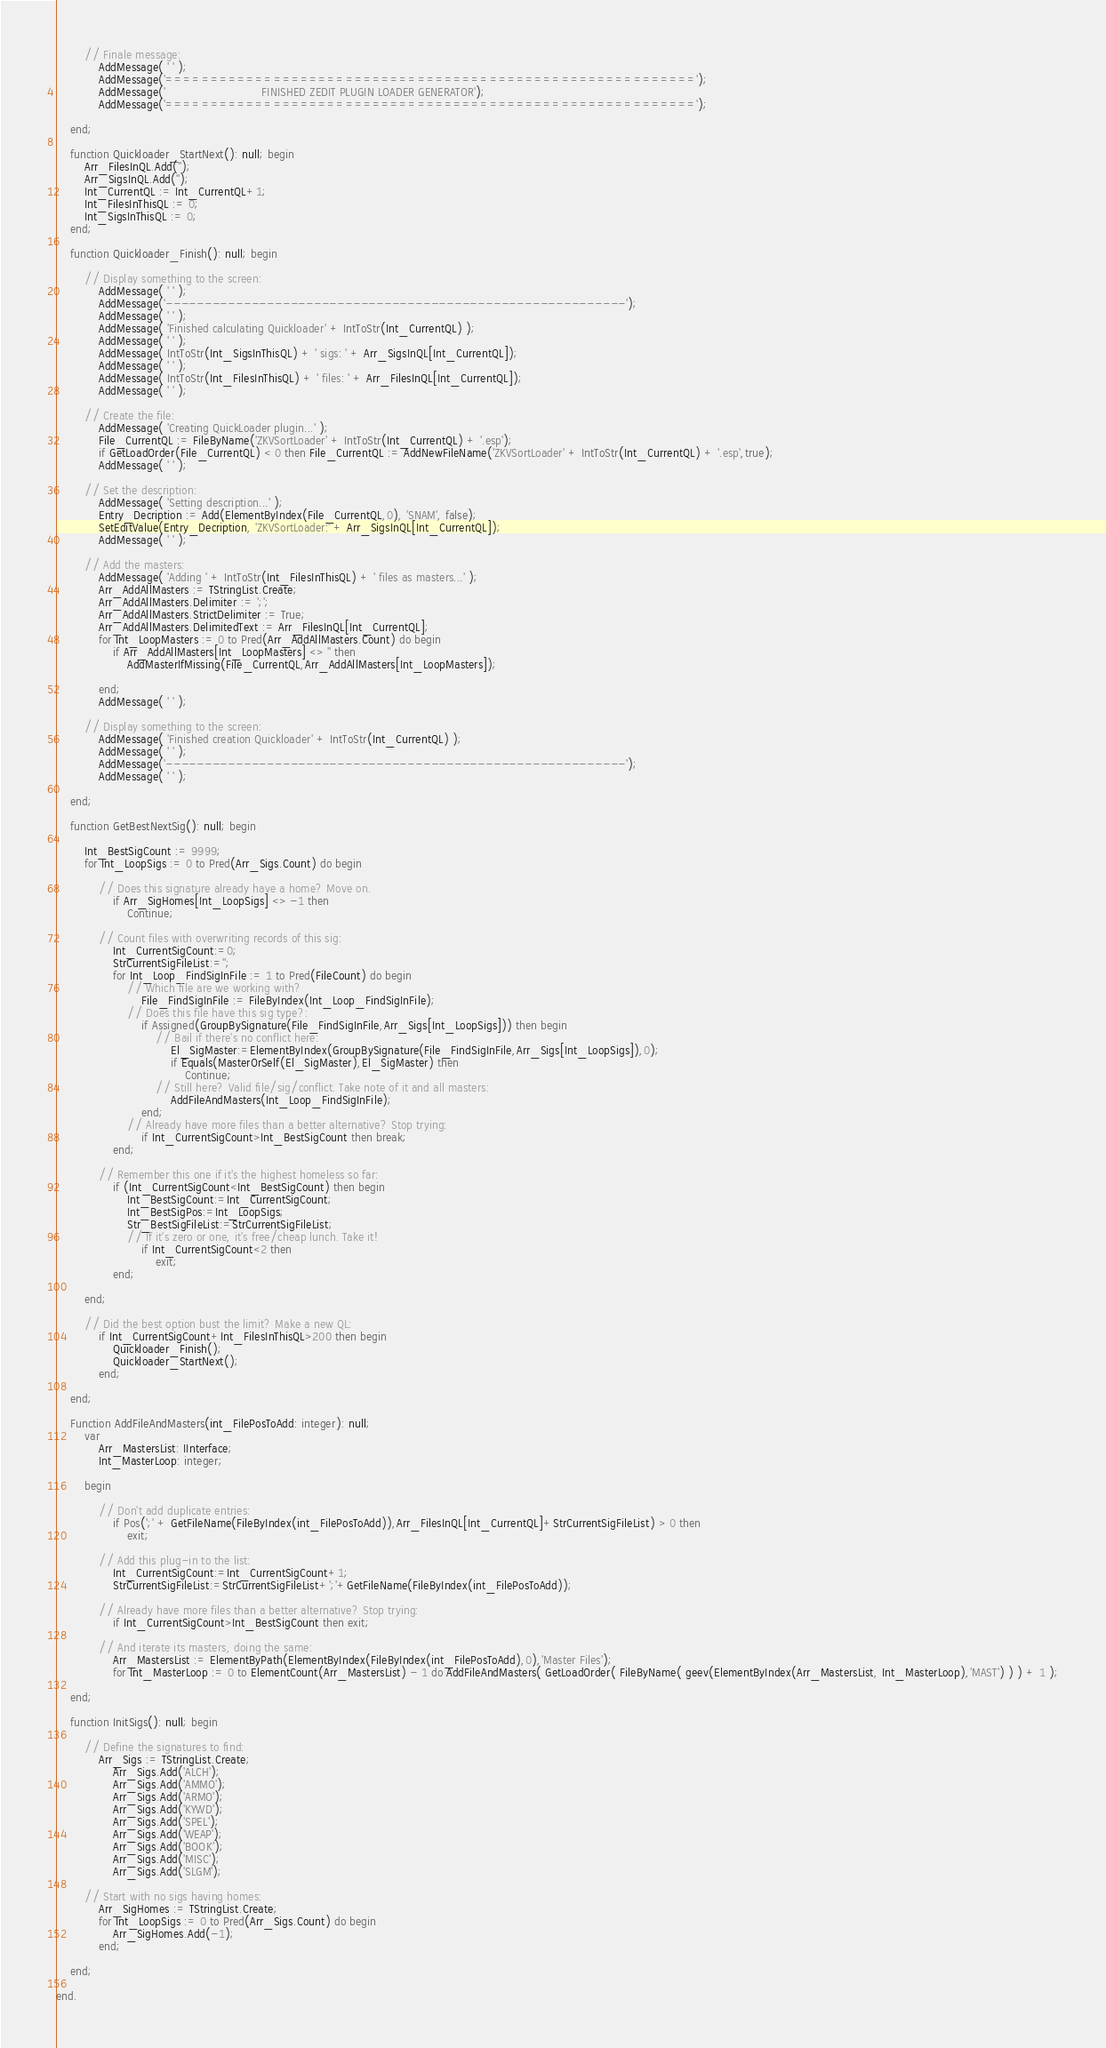Convert code to text. <code><loc_0><loc_0><loc_500><loc_500><_Pascal_>
		// Finale message:
			AddMessage( ' ' );
			AddMessage('===========================================================');
			AddMessage('                           FINISHED ZEDIT PLUGIN LOADER GENERATOR');
			AddMessage('===========================================================');

	end;

	function Quickloader_StartNext(): null; begin
		Arr_FilesInQL.Add('');
		Arr_SigsInQL.Add('');
		Int_CurrentQL := Int_CurrentQL+1;
		Int_FilesInThisQL := 0;
		Int_SigsInThisQL := 0;
	end;

	function Quickloader_Finish(): null; begin

		// Display something to the screen:
			AddMessage( ' ' );
			AddMessage('-----------------------------------------------------------');
			AddMessage( ' ' );
			AddMessage( 'Finished calculating Quickloader' + IntToStr(Int_CurrentQL) );
			AddMessage( ' ' );
			AddMessage( IntToStr(Int_SigsInThisQL) + ' sigs: ' + Arr_SigsInQL[Int_CurrentQL]);
			AddMessage( ' ' );
			AddMessage( IntToStr(Int_FilesInThisQL) + ' files: ' + Arr_FilesInQL[Int_CurrentQL]);
			AddMessage( ' ' );

		// Create the file:
			AddMessage( 'Creating QuickLoader plugin...' );
			File_CurrentQL := FileByName('ZKVSortLoader' + IntToStr(Int_CurrentQL) + '.esp');
			if GetLoadOrder(File_CurrentQL) < 0 then File_CurrentQL := AddNewFileName('ZKVSortLoader' + IntToStr(Int_CurrentQL) + '.esp',true);
			AddMessage( ' ' );

		// Set the description:
			AddMessage( 'Setting description...' );
			Entry_Decription := Add(ElementByIndex(File_CurrentQL,0), 'SNAM', false);
			SetEditValue(Entry_Decription, 'ZKVSortLoader:' + Arr_SigsInQL[Int_CurrentQL]);
			AddMessage( ' ' );

		// Add the masters:
			AddMessage( 'Adding ' + IntToStr(Int_FilesInThisQL) + ' files as masters...' );
			Arr_AddAllMasters := TStringList.Create;
			Arr_AddAllMasters.Delimiter := ';';
			Arr_AddAllMasters.StrictDelimiter := True;
			Arr_AddAllMasters.DelimitedText := Arr_FilesInQL[Int_CurrentQL];
			for Int_LoopMasters := 0 to Pred(Arr_AddAllMasters.Count) do begin
				if Arr_AddAllMasters[Int_LoopMasters] <> '' then
					AddMasterIfMissing(File_CurrentQL,Arr_AddAllMasters[Int_LoopMasters]);

			end;
			AddMessage( ' ' );

		// Display something to the screen:
			AddMessage( 'Finished creation Quickloader' + IntToStr(Int_CurrentQL) );
			AddMessage( ' ' );
			AddMessage('-----------------------------------------------------------');
			AddMessage( ' ' );

	end;

	function GetBestNextSig(): null; begin

		Int_BestSigCount := 9999;
		for Int_LoopSigs := 0 to Pred(Arr_Sigs.Count) do begin

			// Does this signature already have a home? Move on.
				if Arr_SigHomes[Int_LoopSigs] <> -1 then
					Continue;

			// Count files with overwriting records of this sig:
				Int_CurrentSigCount:=0;
				StrCurrentSigFileList:='';
				for Int_Loop_FindSigInFile := 1 to Pred(FileCount) do begin
					// Which file are we working with?
						File_FindSigInFile := FileByIndex(Int_Loop_FindSigInFile);
					// Does this file have this sig type?:
						if Assigned(GroupBySignature(File_FindSigInFile,Arr_Sigs[Int_LoopSigs])) then begin
							// Bail if there's no conflict here:
								El_SigMaster:=ElementByIndex(GroupBySignature(File_FindSigInFile,Arr_Sigs[Int_LoopSigs]),0);
								if Equals(MasterOrSelf(El_SigMaster),El_SigMaster) then
									Continue;
							// Still here? Valid file/sig/conflict. Take note of it and all masters:
								AddFileAndMasters(Int_Loop_FindSigInFile);
						end;
					// Already have more files than a better alternative? Stop trying:
						if Int_CurrentSigCount>Int_BestSigCount then break;
				end;

			// Remember this one if it's the highest homeless so far:
				if (Int_CurrentSigCount<Int_BestSigCount) then begin
					Int_BestSigCount:=Int_CurrentSigCount;
					Int_BestSigPos:=Int_LoopSigs;
					Str_BestSigFileList:=StrCurrentSigFileList;
					// If it's zero or one, it's free/cheap lunch. Take it!
						if Int_CurrentSigCount<2 then
							exit;
				end;

		end;

		// Did the best option bust the limit? Make a new QL:
			if Int_CurrentSigCount+Int_FilesInThisQL>200 then begin
				Quickloader_Finish();
				Quickloader_StartNext();
			end;

	end;

	Function AddFileAndMasters(int_FilePosToAdd: integer): null;
		var
			Arr_MastersList: IInterface;
			Int_MasterLoop: integer;

		begin

			// Don't add duplicate entries:
				if Pos(';' + GetFileName(FileByIndex(int_FilePosToAdd)),Arr_FilesInQL[Int_CurrentQL]+StrCurrentSigFileList) > 0 then
					exit;

			// Add this plug-in to the list:
				Int_CurrentSigCount:=Int_CurrentSigCount+1;
				StrCurrentSigFileList:=StrCurrentSigFileList+';'+GetFileName(FileByIndex(int_FilePosToAdd));

			// Already have more files than a better alternative? Stop trying:
				if Int_CurrentSigCount>Int_BestSigCount then exit;

			// And iterate its masters, doing the same:
				Arr_MastersList := ElementByPath(ElementByIndex(FileByIndex(int_FilePosToAdd),0),'Master Files');
				for Int_MasterLoop := 0 to ElementCount(Arr_MastersList) - 1 do AddFileAndMasters( GetLoadOrder( FileByName( geev(ElementByIndex(Arr_MastersList, Int_MasterLoop),'MAST') ) ) + 1 );

	end;

	function InitSigs(): null; begin

		// Define the signatures to find:
			Arr_Sigs := TStringList.Create;
				Arr_Sigs.Add('ALCH');
				Arr_Sigs.Add('AMMO');
				Arr_Sigs.Add('ARMO');
				Arr_Sigs.Add('KYWD');
				Arr_Sigs.Add('SPEL');
				Arr_Sigs.Add('WEAP');
				Arr_Sigs.Add('BOOK');
				Arr_Sigs.Add('MISC');
				Arr_Sigs.Add('SLGM');

		// Start with no sigs having homes:
			Arr_SigHomes := TStringList.Create;
			for Int_LoopSigs := 0 to Pred(Arr_Sigs.Count) do begin
				Arr_SigHomes.Add(-1);
			end;

	end;

end.
</code> 